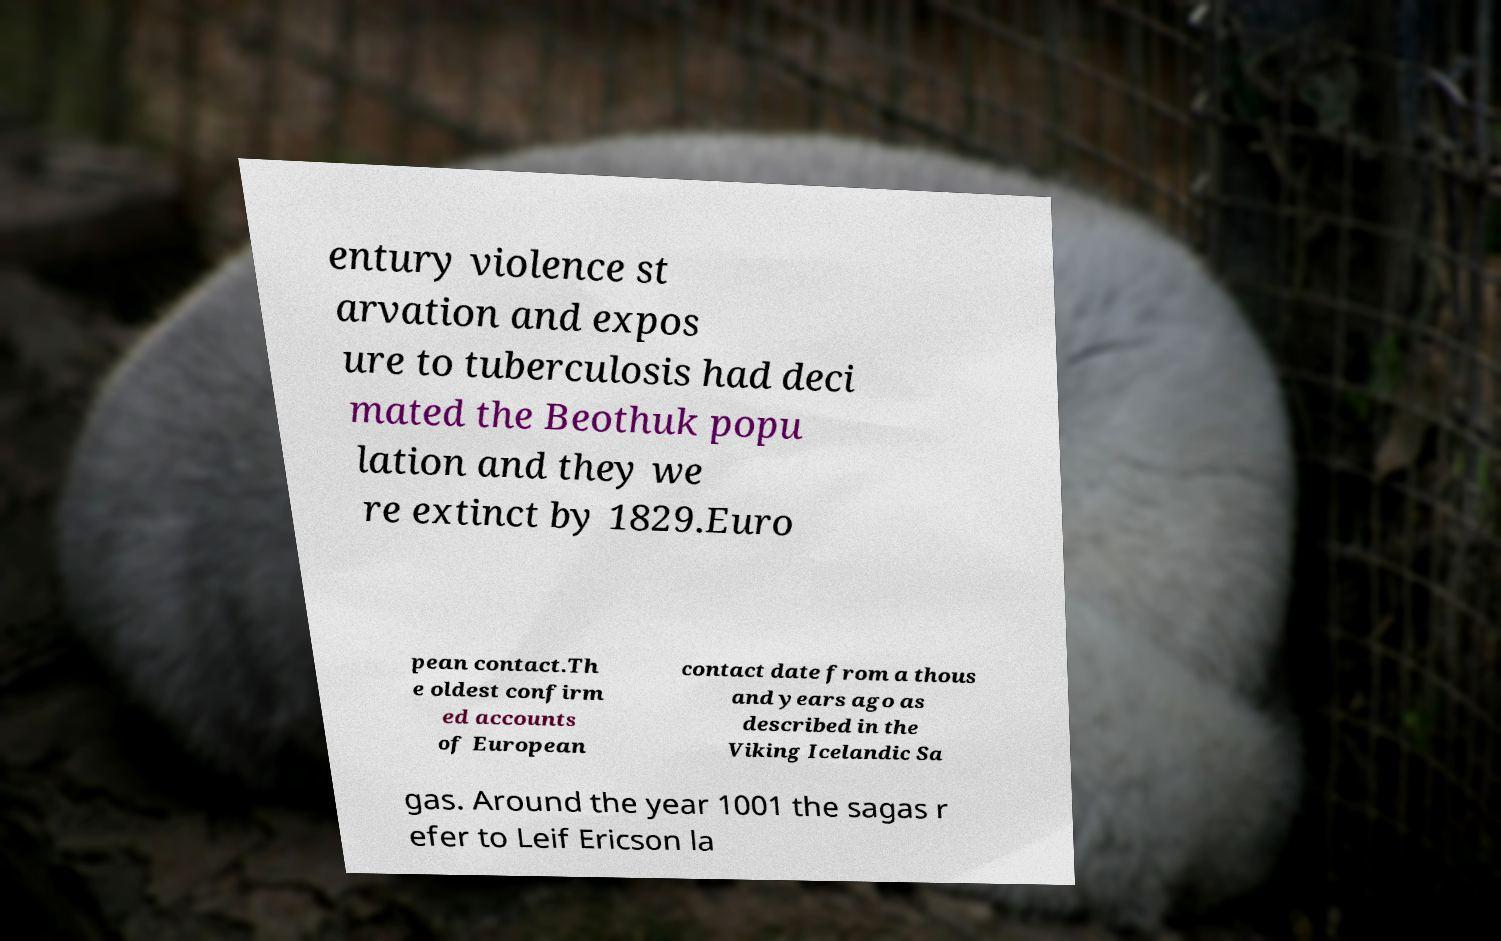Can you read and provide the text displayed in the image?This photo seems to have some interesting text. Can you extract and type it out for me? entury violence st arvation and expos ure to tuberculosis had deci mated the Beothuk popu lation and they we re extinct by 1829.Euro pean contact.Th e oldest confirm ed accounts of European contact date from a thous and years ago as described in the Viking Icelandic Sa gas. Around the year 1001 the sagas r efer to Leif Ericson la 